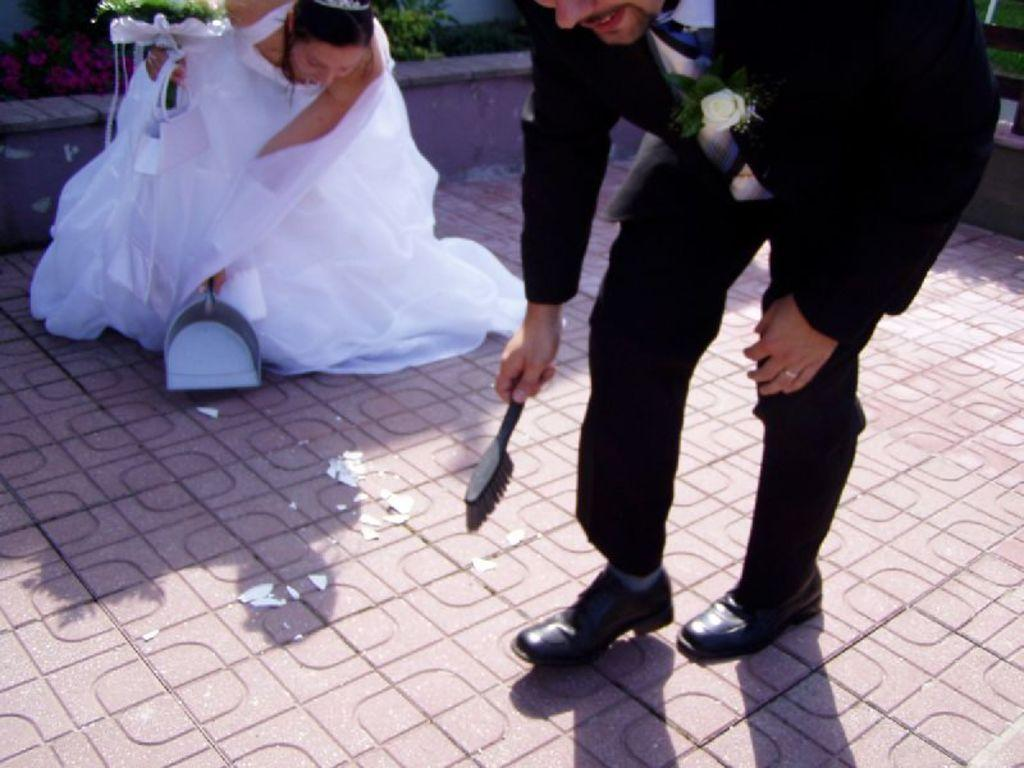What is the surface beneath the man and woman in the image? There is a floor in the image. How many people are present in the image? There is a man and a woman in the image. What are the man and woman doing in the image? The man and woman are bending and holding a stick and a plastic dust pan. What can be seen in the background of the image? There are plants in the background of the image. What type of key is the man using to open the pump in the image? There is no key or pump present in the image. How many forks can be seen on the table in the image? There is no table or fork present in the image. 